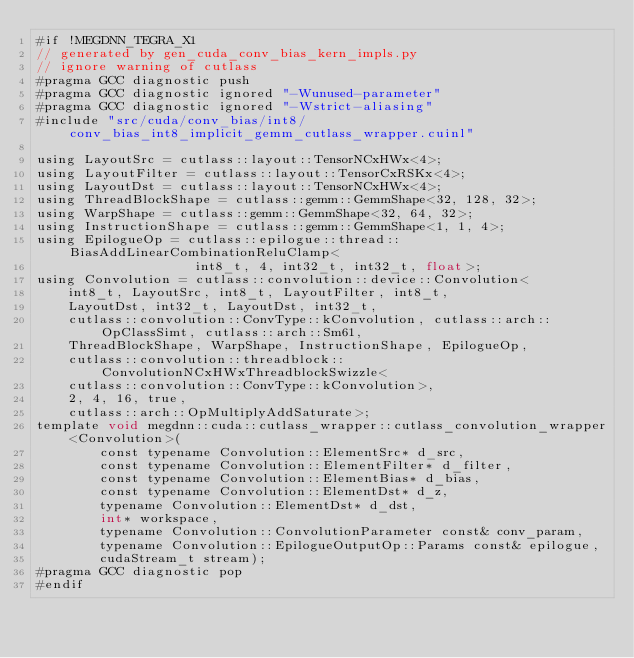Convert code to text. <code><loc_0><loc_0><loc_500><loc_500><_Cuda_>#if !MEGDNN_TEGRA_X1
// generated by gen_cuda_conv_bias_kern_impls.py
// ignore warning of cutlass
#pragma GCC diagnostic push
#pragma GCC diagnostic ignored "-Wunused-parameter"
#pragma GCC diagnostic ignored "-Wstrict-aliasing"
#include "src/cuda/conv_bias/int8/conv_bias_int8_implicit_gemm_cutlass_wrapper.cuinl"

using LayoutSrc = cutlass::layout::TensorNCxHWx<4>;
using LayoutFilter = cutlass::layout::TensorCxRSKx<4>;
using LayoutDst = cutlass::layout::TensorNCxHWx<4>;
using ThreadBlockShape = cutlass::gemm::GemmShape<32, 128, 32>;
using WarpShape = cutlass::gemm::GemmShape<32, 64, 32>;
using InstructionShape = cutlass::gemm::GemmShape<1, 1, 4>;
using EpilogueOp = cutlass::epilogue::thread::BiasAddLinearCombinationReluClamp<
                    int8_t, 4, int32_t, int32_t, float>;
using Convolution = cutlass::convolution::device::Convolution<
    int8_t, LayoutSrc, int8_t, LayoutFilter, int8_t, 
    LayoutDst, int32_t, LayoutDst, int32_t, 
    cutlass::convolution::ConvType::kConvolution, cutlass::arch::OpClassSimt, cutlass::arch::Sm61, 
    ThreadBlockShape, WarpShape, InstructionShape, EpilogueOp, 
    cutlass::convolution::threadblock::ConvolutionNCxHWxThreadblockSwizzle<
    cutlass::convolution::ConvType::kConvolution>, 
    2, 4, 16, true, 
    cutlass::arch::OpMultiplyAddSaturate>;
template void megdnn::cuda::cutlass_wrapper::cutlass_convolution_wrapper<Convolution>(
        const typename Convolution::ElementSrc* d_src, 
        const typename Convolution::ElementFilter* d_filter, 
        const typename Convolution::ElementBias* d_bias, 
        const typename Convolution::ElementDst* d_z, 
        typename Convolution::ElementDst* d_dst, 
        int* workspace, 
        typename Convolution::ConvolutionParameter const& conv_param, 
        typename Convolution::EpilogueOutputOp::Params const& epilogue, 
        cudaStream_t stream);
#pragma GCC diagnostic pop
#endif
</code> 